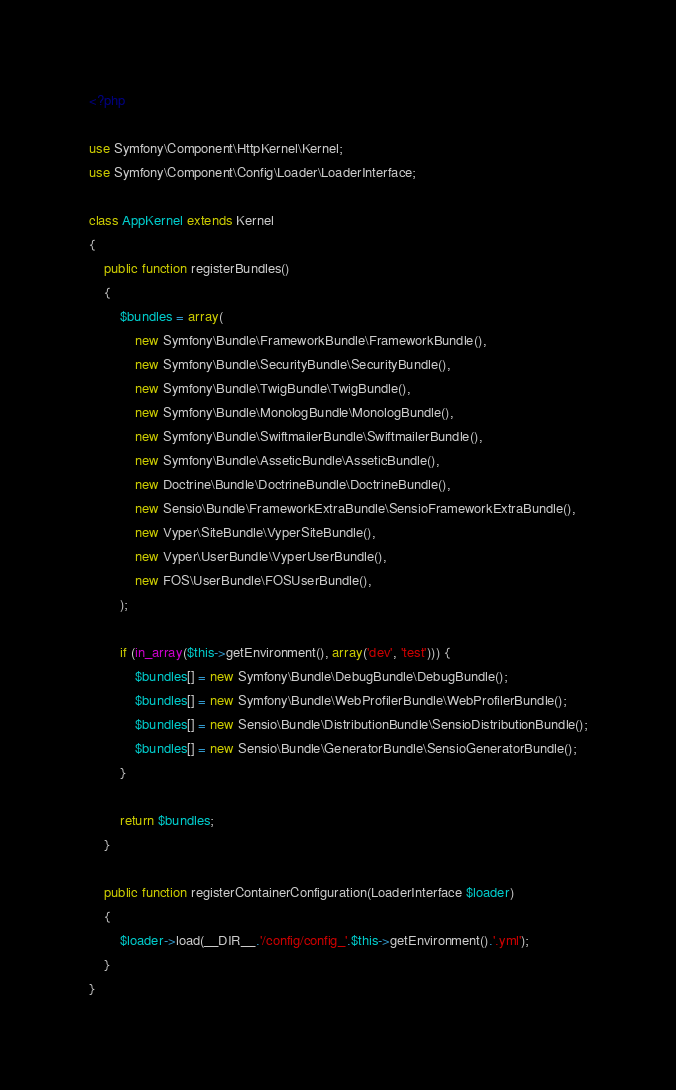<code> <loc_0><loc_0><loc_500><loc_500><_PHP_><?php

use Symfony\Component\HttpKernel\Kernel;
use Symfony\Component\Config\Loader\LoaderInterface;

class AppKernel extends Kernel
{
    public function registerBundles()
    {
        $bundles = array(
            new Symfony\Bundle\FrameworkBundle\FrameworkBundle(),
            new Symfony\Bundle\SecurityBundle\SecurityBundle(),
            new Symfony\Bundle\TwigBundle\TwigBundle(),
            new Symfony\Bundle\MonologBundle\MonologBundle(),
            new Symfony\Bundle\SwiftmailerBundle\SwiftmailerBundle(),
            new Symfony\Bundle\AsseticBundle\AsseticBundle(),
            new Doctrine\Bundle\DoctrineBundle\DoctrineBundle(),
            new Sensio\Bundle\FrameworkExtraBundle\SensioFrameworkExtraBundle(),
            new Vyper\SiteBundle\VyperSiteBundle(),
            new Vyper\UserBundle\VyperUserBundle(),
            new FOS\UserBundle\FOSUserBundle(),
        );

        if (in_array($this->getEnvironment(), array('dev', 'test'))) {
            $bundles[] = new Symfony\Bundle\DebugBundle\DebugBundle();
            $bundles[] = new Symfony\Bundle\WebProfilerBundle\WebProfilerBundle();
            $bundles[] = new Sensio\Bundle\DistributionBundle\SensioDistributionBundle();
            $bundles[] = new Sensio\Bundle\GeneratorBundle\SensioGeneratorBundle();
        }

        return $bundles;
    }

    public function registerContainerConfiguration(LoaderInterface $loader)
    {
        $loader->load(__DIR__.'/config/config_'.$this->getEnvironment().'.yml');
    }
}
</code> 